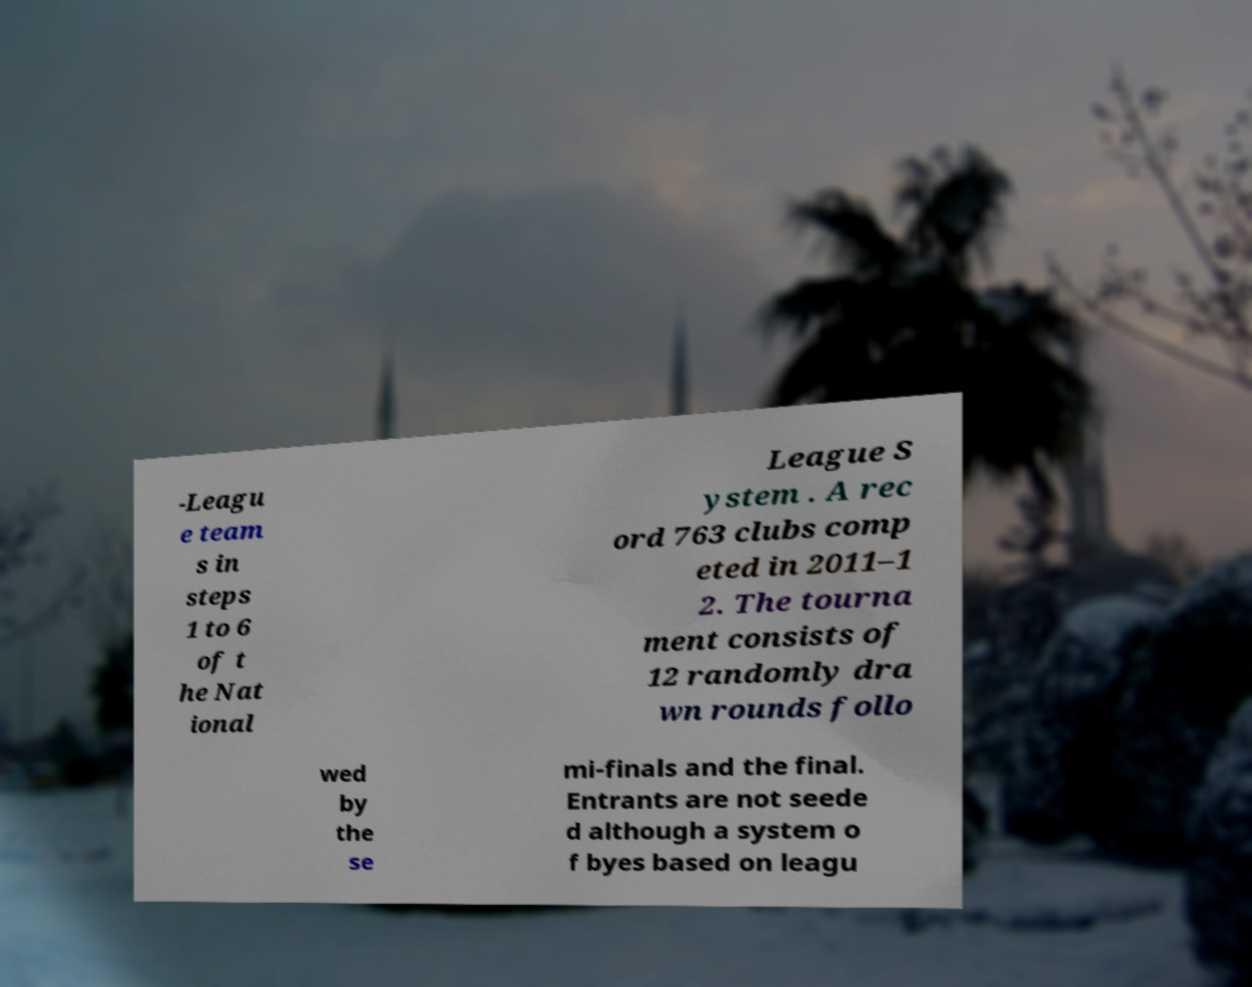Can you accurately transcribe the text from the provided image for me? -Leagu e team s in steps 1 to 6 of t he Nat ional League S ystem . A rec ord 763 clubs comp eted in 2011–1 2. The tourna ment consists of 12 randomly dra wn rounds follo wed by the se mi-finals and the final. Entrants are not seede d although a system o f byes based on leagu 